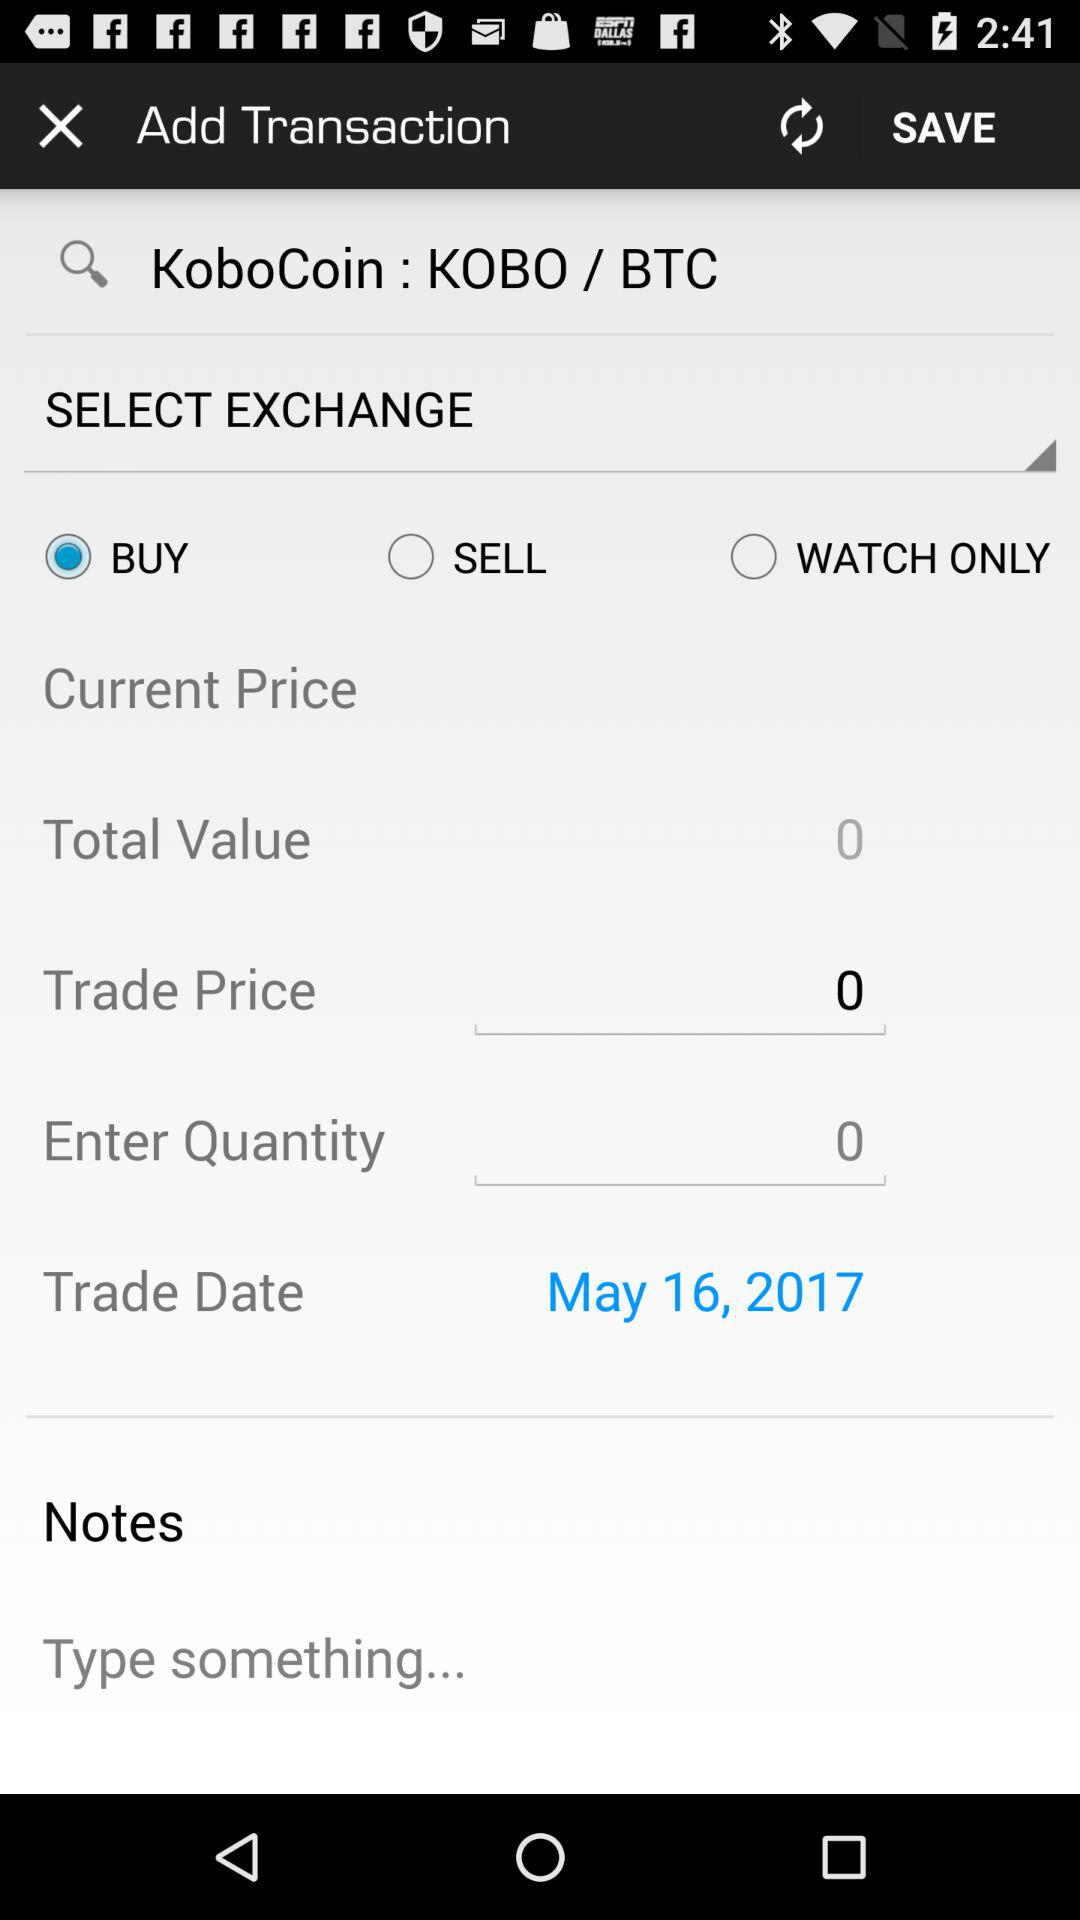Is "SELL" selected or not? "SELL" is not selected. 